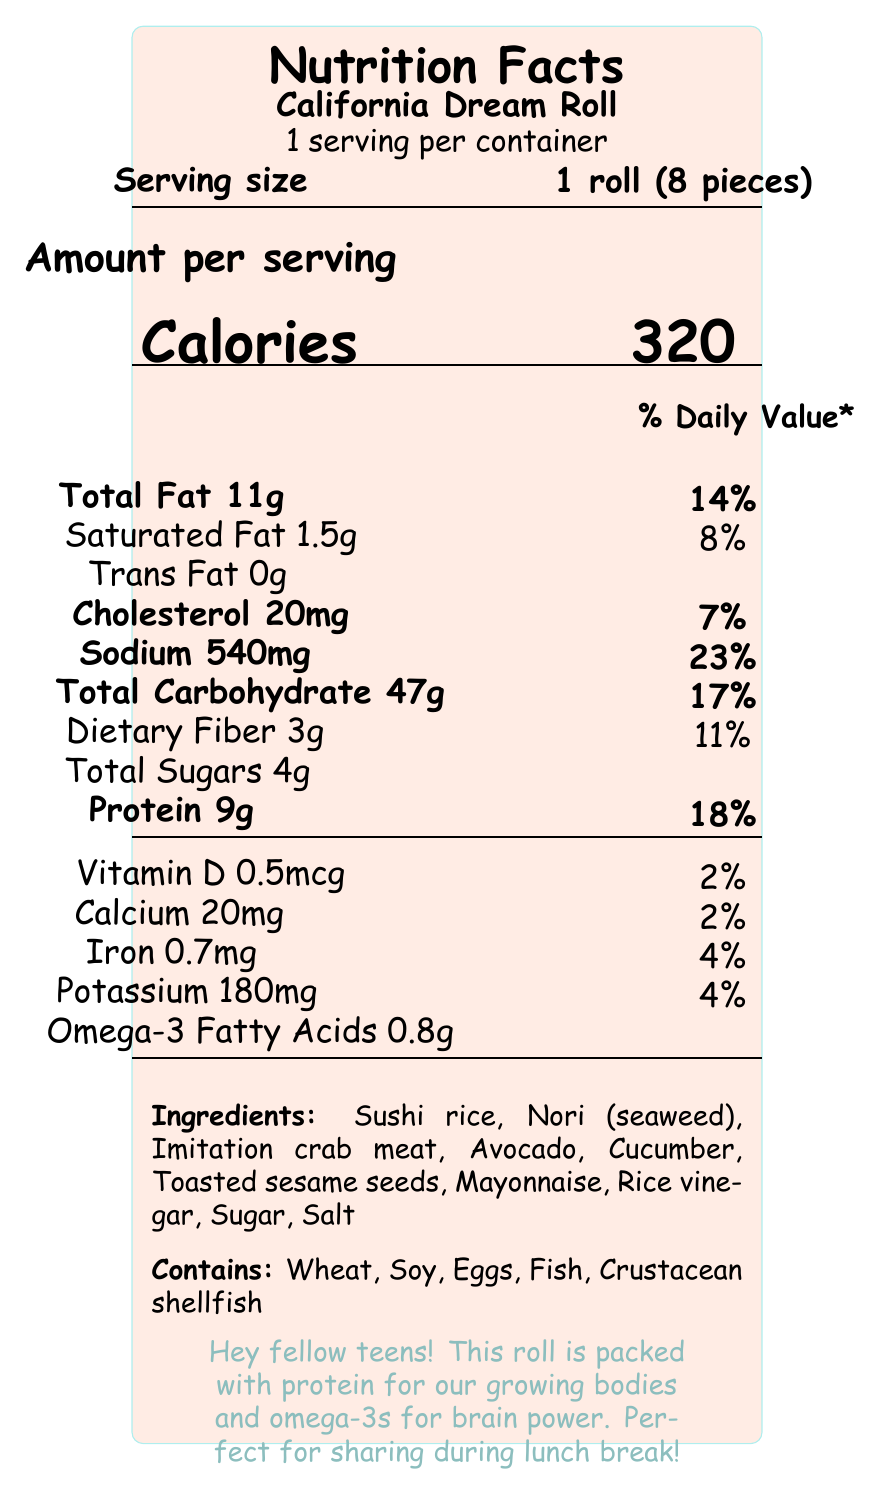how many calories are in one serving of the California Dream Roll? The document states that there are 320 calories per serving.
Answer: 320 how much protein does the California Dream Roll contain? The document lists 9g of protein per serving, which is prominently mentioned under the protein section.
Answer: 9g what is the serving size for the California Dream Roll? The serving size is clearly mentioned as "1 roll (8 pieces)" at the top of the document.
Answer: 1 roll (8 pieces) what percentage of the daily value for sodium does one serving of the California Dream Roll provide? The sodium content is shown as 540mg, which is 23% of the daily value.
Answer: 23% how much omega-3 fatty acids are in one serving of the California Dream Roll? The document states that one serving contains 0.8g of omega-3 fatty acids.
Answer: 0.8g what are the top two allergens found in the California Dream Roll? Under the "Contains" section, wheat and soy are listed among the allergens.
Answer: Wheat, Soy which of the following is NOT an ingredient in the California Dream Roll? A. Sushi rice B. Avocado C. Tuna D. Cucumber The ingredients section lists sushi rice, avocado, cucumber, but does not mention tuna.
Answer: C how many grams of total fat are in a serving of the California Dream Roll? A. 9g B. 11g C. 14g D. 18g The total fat content is listed as 11g per serving.
Answer: B does the California Dream Roll contain any trans fat? The document specifies that the trans fat content is 0g.
Answer: No is the California Dream Roll a good source of calcium? The roll contains only 20mg of calcium, which is 2% of the daily value, indicating it's not a significant source.
Answer: No how many allergens are present in the California Dream Roll? The document lists 5 allergens: Wheat, Soy, Eggs, Fish, and Crustacean shellfish.
Answer: 5 why might the California Dream Roll be considered teen-friendly? The document mentions several teen-friendly notes highlighting its nutritional benefits and social aspects.
Answer: Great source of protein for growing bodies, Omega-3 fatty acids support brain health, Perfect for sharing with friends during lunch break, Low in saturated fat how much is the daily value percentage for dietary fiber in the California Dream Roll? The dietary fiber content is 3g, which accounts for 11% of the daily value.
Answer: 11% how many vitamins and minerals are listed with their daily values? The vitamins and minerals listed are Vitamin D (2%), Calcium (2%), Iron (4%), and Potassium (4%).
Answer: 4 what is the role of the ingredients section in the document? The ingredients section provides a detailed list of all the components used in making the sushi roll.
Answer: Lists all the ingredients used in the California Dream Roll. can you tell from the document when the California Dream Roll was prepared? The document does not provide specific information about the exact preparation time of the roll.
Answer: No 